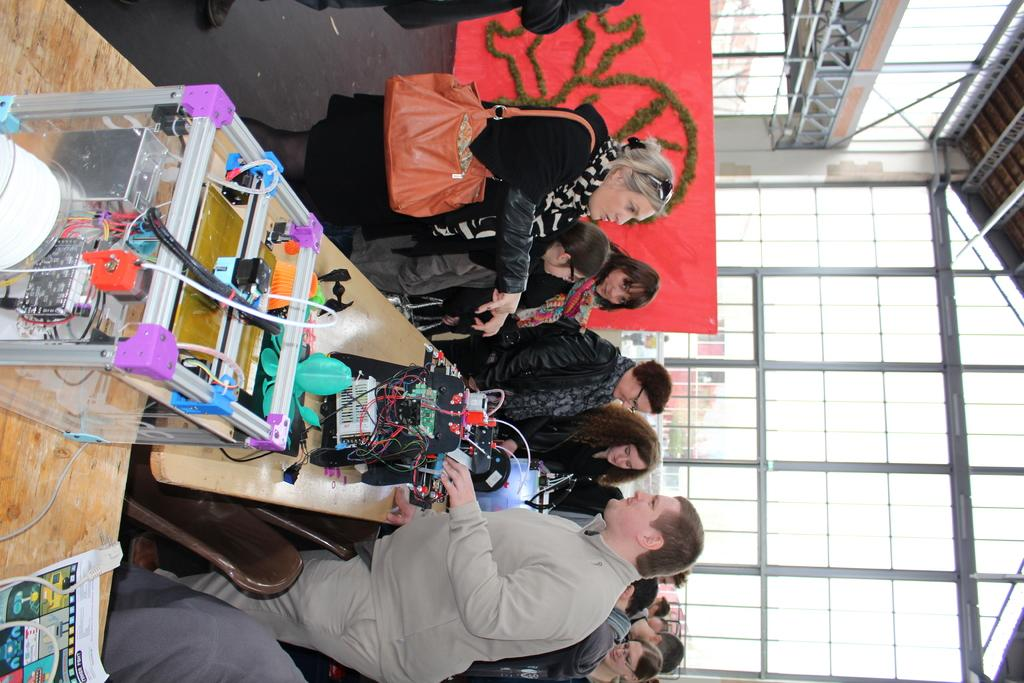How many people can be seen in the image? There are many people standing in the image. What can be found on a table in the image? There are objects placed on a table in the image. What type of structures are visible in the image? There are buildings in the image. What type of vegetation is present in the image? There are trees in the image. Who is the owner of the flowers in the image? There are no flowers present in the image. What is the porter carrying in the image? There is no porter present in the image. 